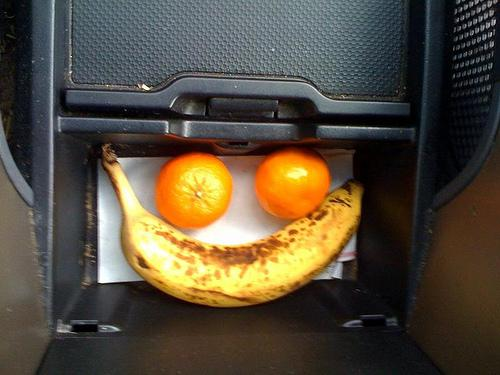Question: where is this scene?
Choices:
A. In a train.
B. In a car.
C. On a boat.
D. In a hot-air balloon.
Answer with the letter. Answer: B Question: what is present?
Choices:
A. Orange fruit.
B. Green plant.
C. Yellow dog.
D. Gray rock.
Answer with the letter. Answer: A Question: why are there fruits?
Choices:
A. They're being picked.
B. To be eaten.
C. They are ripening.
D. Because it's natural for them to grow here.
Answer with the letter. Answer: B Question: how is the photo?
Choices:
A. Fuzzy.
B. Clear.
C. Tilted.
D. Half exposed.
Answer with the letter. Answer: B Question: who is present?
Choices:
A. One person.
B. Two people.
C. Three people.
D. No one.
Answer with the letter. Answer: D Question: what color are the oranges?
Choices:
A. Red.
B. Yellow.
C. Orange.
D. Light orange.
Answer with the letter. Answer: C 